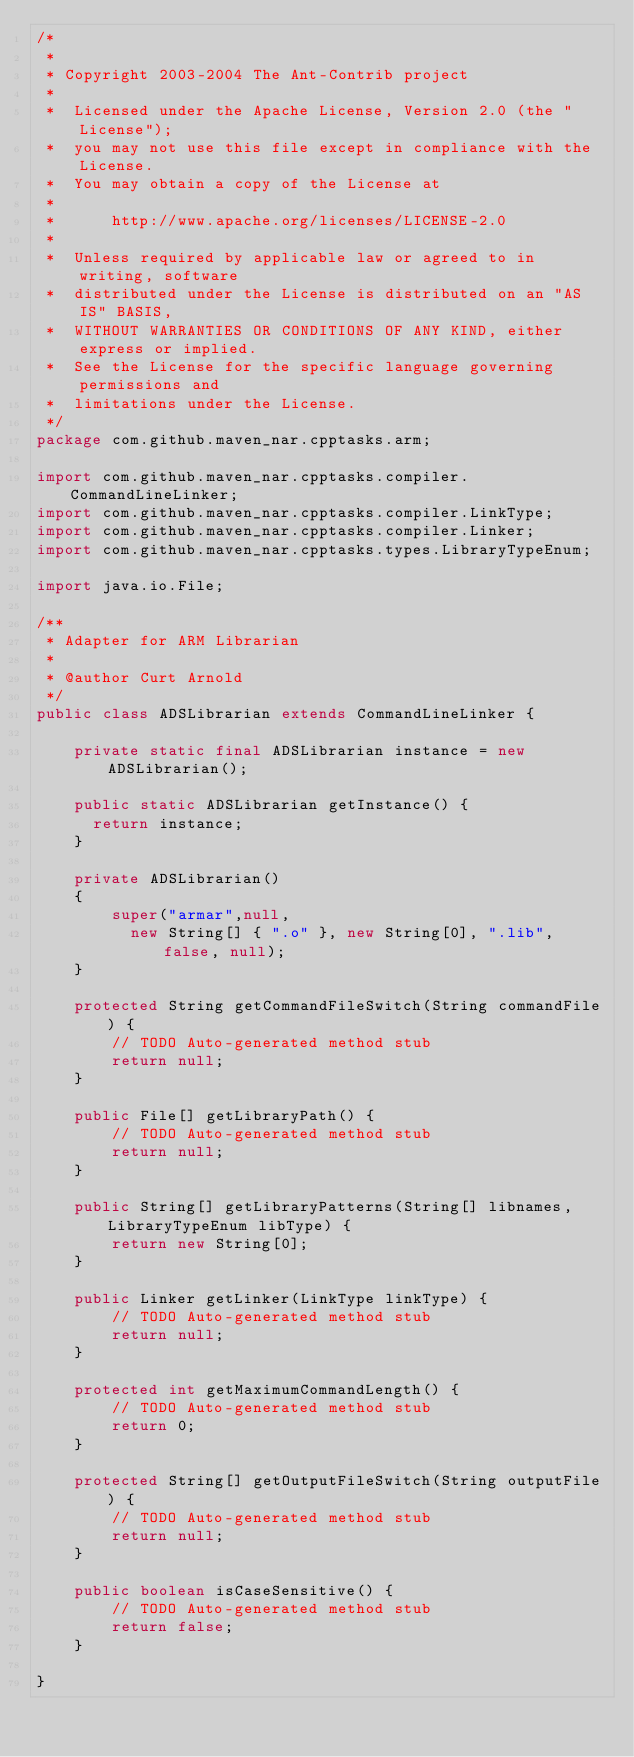<code> <loc_0><loc_0><loc_500><loc_500><_Java_>/*
 * 
 * Copyright 2003-2004 The Ant-Contrib project
 *
 *  Licensed under the Apache License, Version 2.0 (the "License");
 *  you may not use this file except in compliance with the License.
 *  You may obtain a copy of the License at
 *
 *      http://www.apache.org/licenses/LICENSE-2.0
 *
 *  Unless required by applicable law or agreed to in writing, software
 *  distributed under the License is distributed on an "AS IS" BASIS,
 *  WITHOUT WARRANTIES OR CONDITIONS OF ANY KIND, either express or implied.
 *  See the License for the specific language governing permissions and
 *  limitations under the License.
 */
package com.github.maven_nar.cpptasks.arm;

import com.github.maven_nar.cpptasks.compiler.CommandLineLinker;
import com.github.maven_nar.cpptasks.compiler.LinkType;
import com.github.maven_nar.cpptasks.compiler.Linker;
import com.github.maven_nar.cpptasks.types.LibraryTypeEnum;

import java.io.File;

/**
 * Adapter for ARM Librarian
 *
 * @author Curt Arnold
 */
public class ADSLibrarian extends CommandLineLinker {

    private static final ADSLibrarian instance = new ADSLibrarian();

    public static ADSLibrarian getInstance() {
      return instance;
    }

    private ADSLibrarian()
    {
        super("armar",null,
          new String[] { ".o" }, new String[0], ".lib", false, null);
    }

    protected String getCommandFileSwitch(String commandFile) {
        // TODO Auto-generated method stub
        return null;
    }

    public File[] getLibraryPath() {
        // TODO Auto-generated method stub
        return null;
    }

    public String[] getLibraryPatterns(String[] libnames, LibraryTypeEnum libType) {
        return new String[0];
    }

    public Linker getLinker(LinkType linkType) {
        // TODO Auto-generated method stub
        return null;
    }

    protected int getMaximumCommandLength() {
        // TODO Auto-generated method stub
        return 0;
    }

    protected String[] getOutputFileSwitch(String outputFile) {
        // TODO Auto-generated method stub
        return null;
    }

    public boolean isCaseSensitive() {
        // TODO Auto-generated method stub
        return false;
    }

}
</code> 